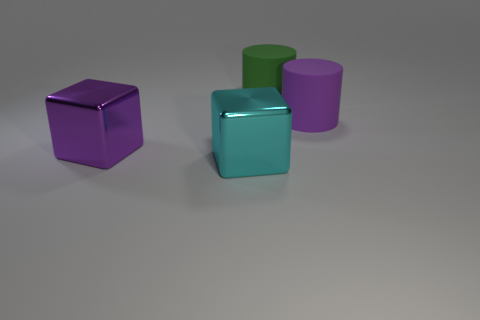How many tiny things are either green matte objects or metallic things?
Your response must be concise. 0. The large object that is in front of the metal block behind the cyan cube on the left side of the big green cylinder is made of what material?
Provide a short and direct response. Metal. What number of rubber objects are either small blocks or cyan objects?
Your answer should be very brief. 0. How many red objects are either large shiny cubes or cylinders?
Give a very brief answer. 0. Is the material of the cyan thing the same as the large green thing?
Ensure brevity in your answer.  No. Are there the same number of large purple things on the left side of the purple cylinder and large green rubber objects that are left of the big cyan shiny thing?
Offer a terse response. No. What material is the purple object that is the same shape as the big green matte thing?
Your answer should be very brief. Rubber. There is a green thing that is on the right side of the metal object left of the big object in front of the purple cube; what is its shape?
Keep it short and to the point. Cylinder. Is the number of cyan metal blocks behind the big cyan cube greater than the number of purple matte cubes?
Provide a short and direct response. No. There is a purple thing right of the cyan thing; is it the same shape as the purple metallic object?
Give a very brief answer. No. 